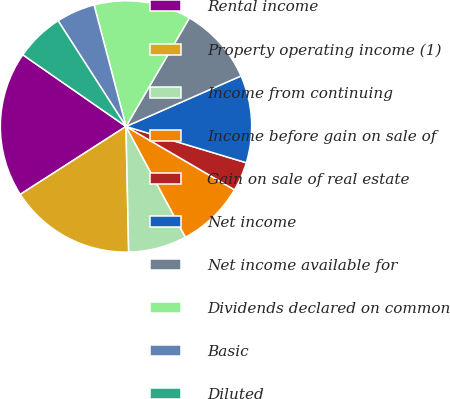Convert chart. <chart><loc_0><loc_0><loc_500><loc_500><pie_chart><fcel>Rental income<fcel>Property operating income (1)<fcel>Income from continuing<fcel>Income before gain on sale of<fcel>Gain on sale of real estate<fcel>Net income<fcel>Net income available for<fcel>Dividends declared on common<fcel>Basic<fcel>Diluted<nl><fcel>18.75%<fcel>16.25%<fcel>7.5%<fcel>8.75%<fcel>3.75%<fcel>11.25%<fcel>10.0%<fcel>12.5%<fcel>5.0%<fcel>6.25%<nl></chart> 